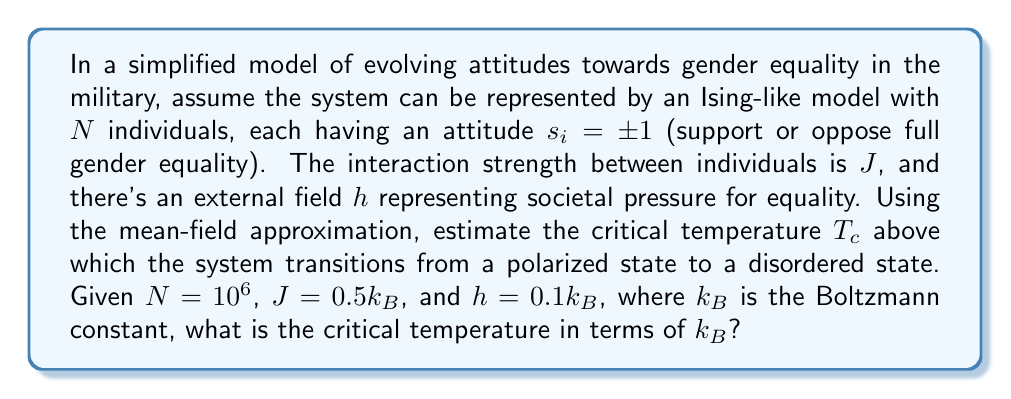Can you solve this math problem? To solve this problem, we'll use the mean-field approximation for the Ising model:

1) In the mean-field theory, the critical temperature $T_c$ for a system with no external field is given by:

   $$T_c = \frac{zJ}{k_B}$$

   where $z$ is the number of nearest neighbors.

2) In our case, we have a small external field $h$. We can approximate the effect of this field by modifying the critical temperature equation:

   $$T_c \approx \frac{zJ}{k_B} + \frac{h}{k_B}$$

3) In a fully connected system (which is often assumed in mean-field theory), each individual interacts with all others. So, $z = N - 1 \approx N$ for large $N$.

4) Substituting the given values:

   $$T_c \approx \frac{N \cdot 0.5k_B}{k_B} + \frac{0.1k_B}{k_B}$$

5) Simplify:

   $$T_c \approx 0.5N + 0.1$$

6) With $N = 10^6$:

   $$T_c \approx 0.5 \cdot 10^6 + 0.1 \approx 5 \cdot 10^5$$

Therefore, the critical temperature is approximately $5 \cdot 10^5$ in terms of $k_B$.
Answer: $5 \cdot 10^5 k_B$ 